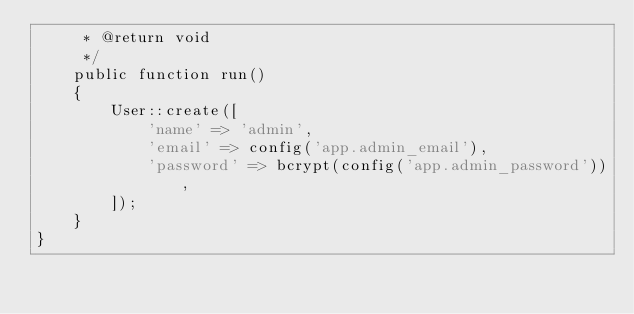Convert code to text. <code><loc_0><loc_0><loc_500><loc_500><_PHP_>     * @return void
     */
    public function run()
    {
        User::create([
            'name' => 'admin',
            'email' => config('app.admin_email'),
            'password' => bcrypt(config('app.admin_password')),
        ]);
    }
}
</code> 